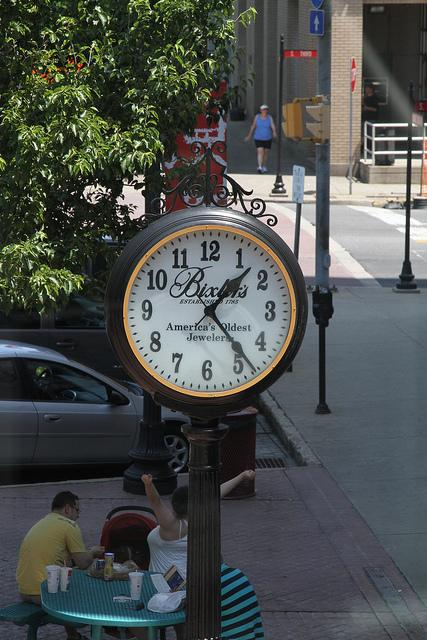What is the highest number that is visible?

Choices:
A) 34
B) 12
C) 68
D) 22 12 